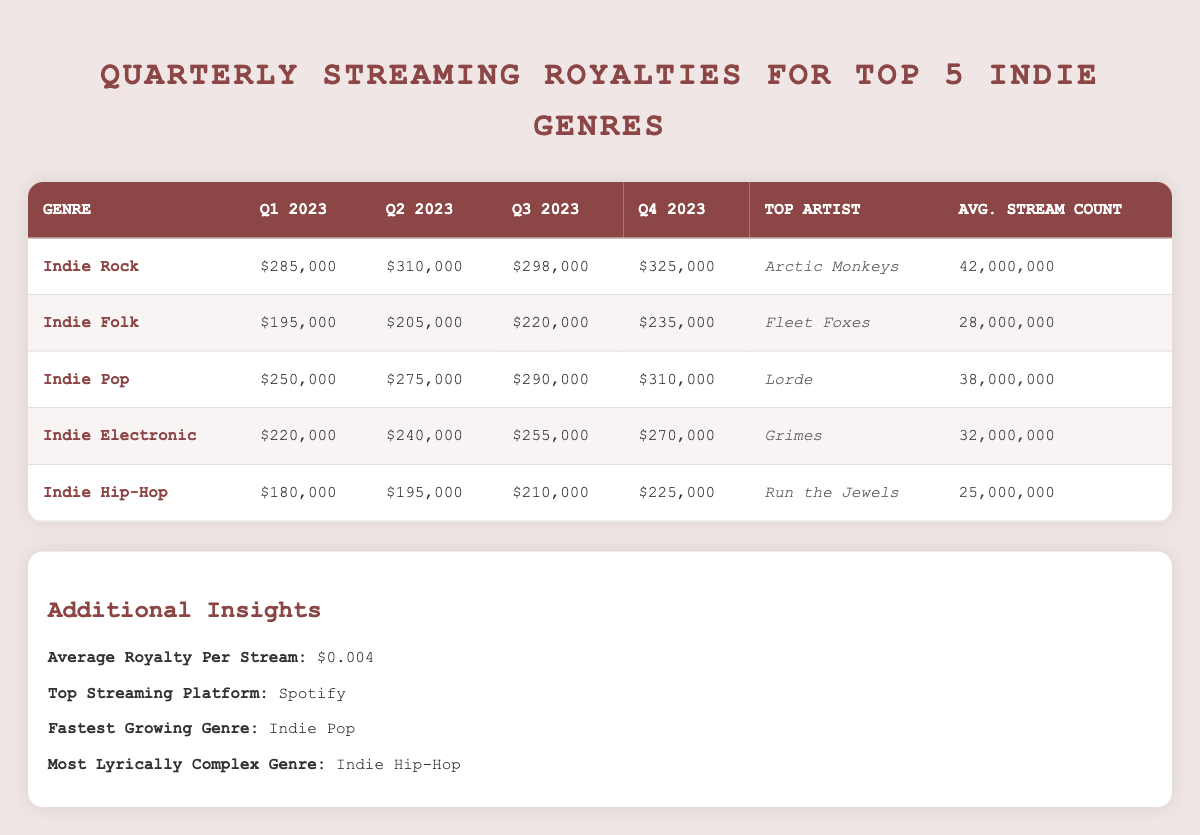What were the quarterly royalties for Indie Pop in Q4 2023? According to the table, the royalties for Indie Pop in Q4 2023 are listed as $310,000.
Answer: $310,000 Who is the top artist for the Indie Folk genre? The table indicates that the top artist for Indie Folk is Fleet Foxes.
Answer: Fleet Foxes What is the average royalty for Indie Electronic across the four quarters? To find the average: (220,000 + 240,000 + 255,000 + 270,000) / 4 = 245,000. Therefore, the average quarterly royalty for Indie Electronic is $245,000.
Answer: $245,000 Did Indie Hip-Hop have the highest average stream count among the top indie genres? By comparing the average stream counts from the table: Indie Rock (42,000,000), Indie Folk (28,000,000), Indie Pop (38,000,000), Indie Electronic (32,000,000), and Indie Hip-Hop (25,000,000), it can be seen that Indie Hip-Hop does not have the highest average; Indie Rock does.
Answer: No What is the difference in quarterly royalties between Q1 2023 and Q2 2023 for Indie Rock? The royalties for Indie Rock in Q1 2023 are $285,000 and in Q2 2023 are $310,000. The difference is $310,000 - $285,000 = $25,000.
Answer: $25,000 Is Spotify the top streaming platform for all indie genres listed? The table highlights that Spotify is noted as the top streaming platform, but it does not provide details on whether it is the top platform for every specific genre listed. Therefore, we cannot confirm that for all.
Answer: Yes What can you infer about the growth trend for Indie Pop from Q1 2023 to Q4 2023? Looking at the quarterly royalties for Indie Pop: Q1 2023 - $250,000, Q2 2023 - $275,000, Q3 2023 - $290,000, Q4 2023 - $310,000, we see consistent increases each quarter, indicating a positive growth trend.
Answer: Positive growth trend What genre has shown the least amount of royalties in Q3 2023? The royalties for Q3 2023 by genre are: Indie Rock ($298,000), Indie Folk ($220,000), Indie Pop ($290,000), Indie Electronic ($255,000), and Indie Hip-Hop ($210,000). The least amount recorded is for Indie Hip-Hop at $210,000.
Answer: Indie Hip-Hop 